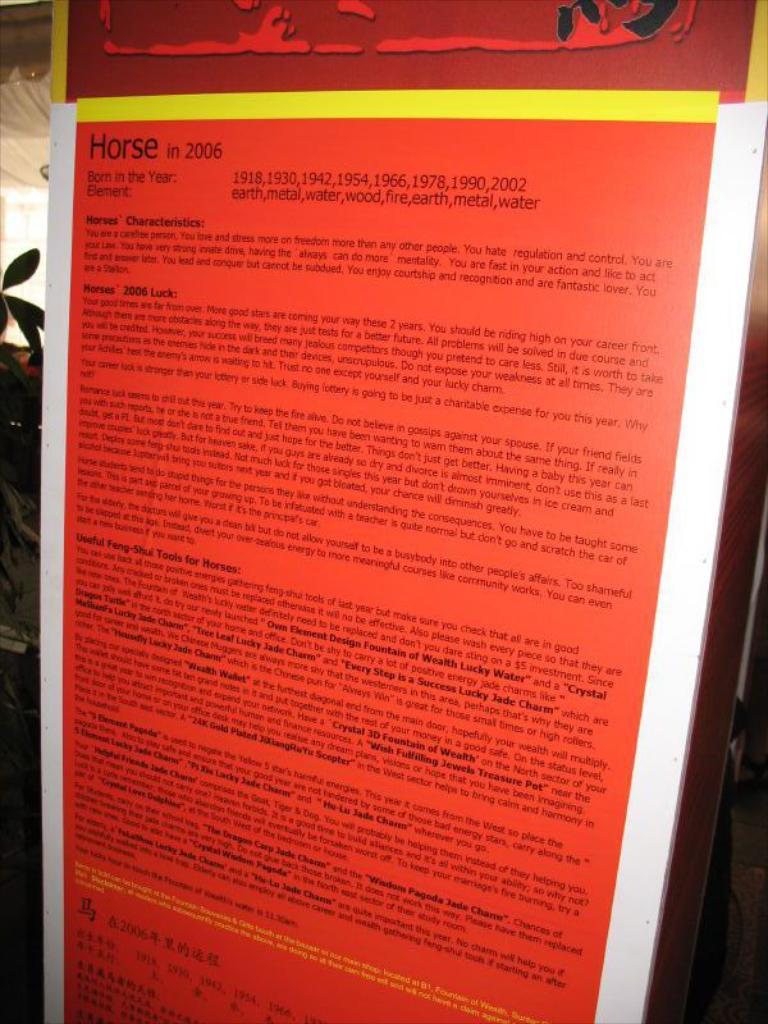<image>
Share a concise interpretation of the image provided. Red background poster about horses in 2006 with all text. 